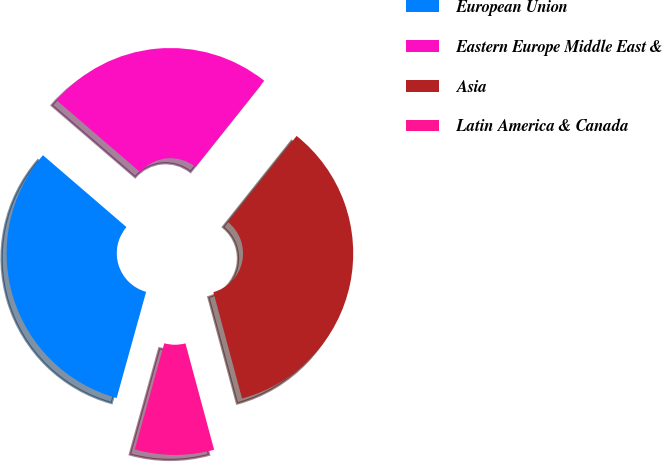<chart> <loc_0><loc_0><loc_500><loc_500><pie_chart><fcel>European Union<fcel>Eastern Europe Middle East &<fcel>Asia<fcel>Latin America & Canada<nl><fcel>32.0%<fcel>24.4%<fcel>35.1%<fcel>8.5%<nl></chart> 